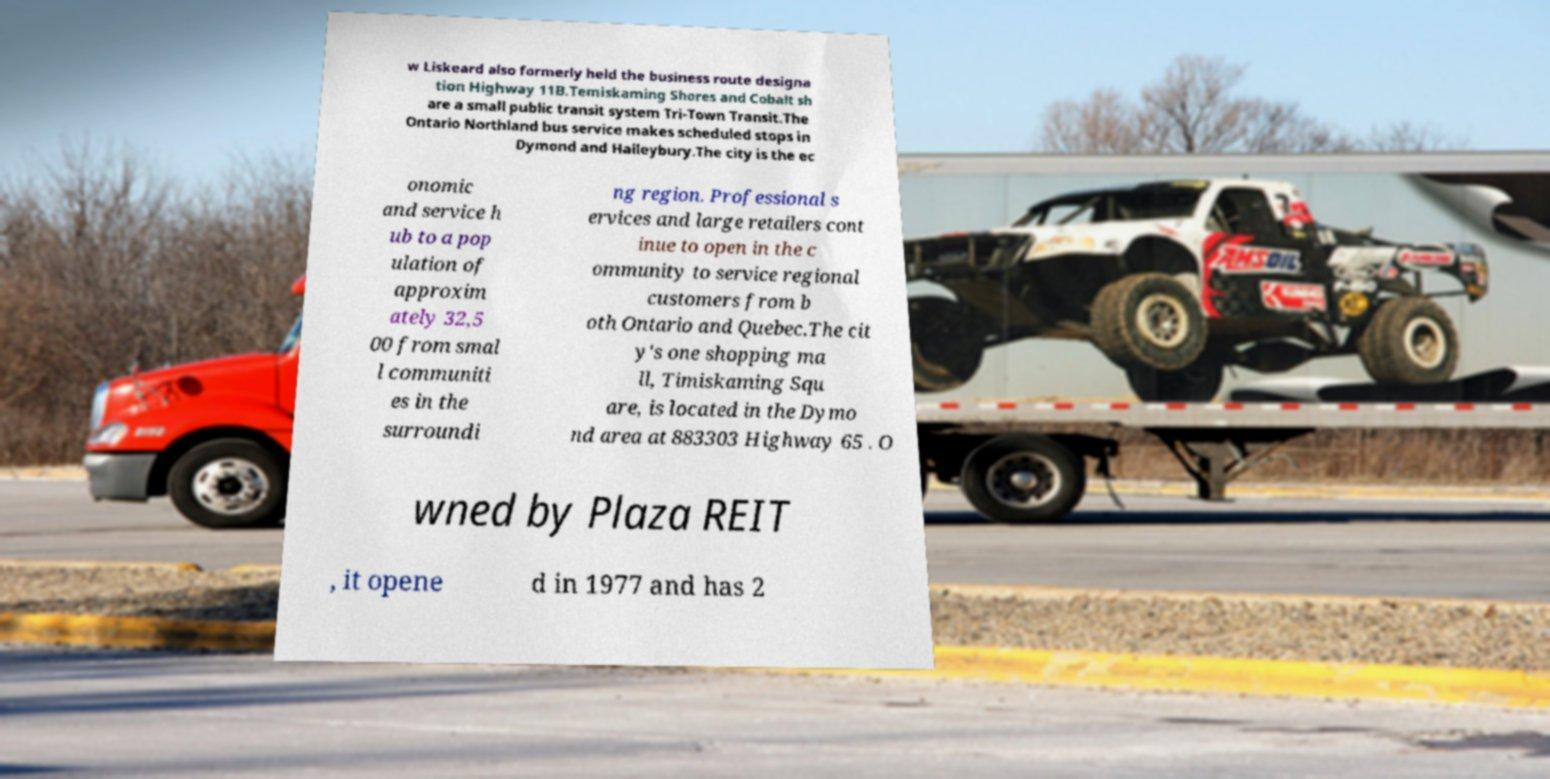Could you extract and type out the text from this image? w Liskeard also formerly held the business route designa tion Highway 11B.Temiskaming Shores and Cobalt sh are a small public transit system Tri-Town Transit.The Ontario Northland bus service makes scheduled stops in Dymond and Haileybury.The city is the ec onomic and service h ub to a pop ulation of approxim ately 32,5 00 from smal l communiti es in the surroundi ng region. Professional s ervices and large retailers cont inue to open in the c ommunity to service regional customers from b oth Ontario and Quebec.The cit y's one shopping ma ll, Timiskaming Squ are, is located in the Dymo nd area at 883303 Highway 65 . O wned by Plaza REIT , it opene d in 1977 and has 2 